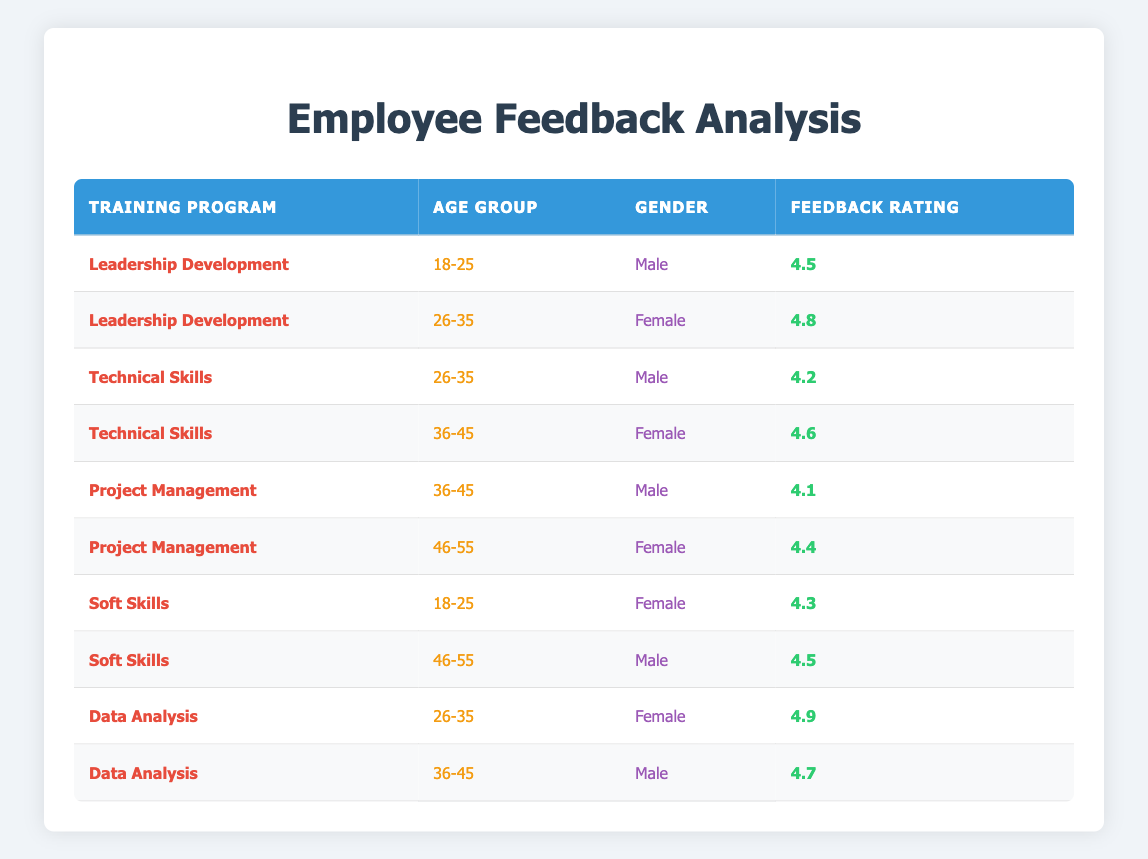What is the feedback rating for the "Leadership Development" program among males in the 18-25 age group? The table shows that the "Leadership Development" program has a feedback rating of 4.5 for males in the 18-25 age group.
Answer: 4.5 What is the feedback rating for females in the "Technical Skills" program aged 36-45? According to the table, females in the "Technical Skills" program of the 36-45 age group have a feedback rating of 4.6.
Answer: 4.6 Is there a "Data Analysis" feedback rating for males in the age group 26-35? The table confirms that there is a feedback rating of 4.9 for females; however, there is no feedback rating listed for males in the "Data Analysis" program in the 26-35 age group.
Answer: No Which training program received the highest feedback rating from females? The highest feedback rating from females in the table is 4.9, attributed to the "Data Analysis" program, as there are no other ratings above that.
Answer: Data Analysis What is the average feedback rating for the "Soft Skills" training program? There are two rows for the "Soft Skills" program: 4.3 and 4.5. Adding them gives 8.8, and dividing by 2 (the number of ratings) results in an average of 4.4.
Answer: 4.4 What is the feedback rating difference between the "Project Management" program for males aged 36-45 and females aged 46-55? The feedback rating for "Project Management" males aged 36-45 is 4.1, and for females aged 46-55, it is 4.4. The difference is calculated as 4.4 - 4.1 = 0.3.
Answer: 0.3 Are there any programs where the ratings for females exceed those for males in all age groups? Evaluating the programs: "Leadership Development" shows a female rating of 4.8 and a male rating of 4.5; "Technical Skills" female rating is 4.6 against a male rating of 4.2; for "Project Management," females are rated higher; for "Soft Skills," the female rating is 4.3 compared to a male rating of 4.5. Therefore, females do exceed ratings for "Leadership Development," "Technical Skills," and "Project Management," but not for "Soft Skills".
Answer: Yes Which age group has the highest feedback rating in the "Data Analysis" program? The table indicates that the highest feedback rating in the "Data Analysis" program is 4.9 for females in the 26-35 age group, making this the highest overall rating in that program.
Answer: 26-35 What is the overall average feedback rating across all training programs? Summing up all ratings (4.5, 4.8, 4.2, 4.6, 4.1, 4.4, 4.3, 4.5, 4.9, 4.7 = 44.1) gives 10 ratings. The average is calculated as 44.1/10 = 4.41.
Answer: 4.41 